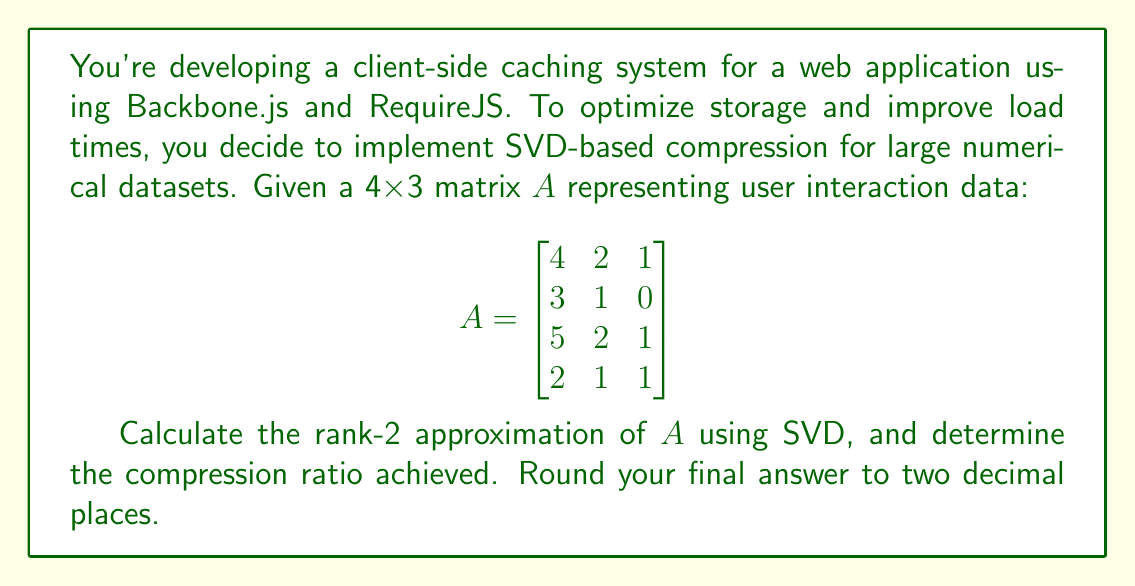Help me with this question. To solve this problem, we'll follow these steps:

1) Compute the SVD of matrix $A$:
   $A = U\Sigma V^T$

2) Truncate the SVD to rank-2:
   $A_2 = U_2\Sigma_2 V_2^T$

3) Calculate the compression ratio

Step 1: Computing the SVD

Using a calculator or computational tool, we get:

$U = \begin{bmatrix}
-0.6412 & -0.0988 & 0.7071 & 0.2887 \\
-0.4263 & -0.2716 & -0.7071 & 0.5000 \\
-0.6284 & 0.0494 & 0 & -0.7761 \\
-0.1311 & 0.9563 & 0 & 0.2613
\end{bmatrix}$

$\Sigma = \begin{bmatrix}
7.3485 & 0 & 0 \\
0 & 0.8564 & 0 \\
0 & 0 & 0.3660 \\
0 & 0 & 0
\end{bmatrix}$

$V^T = \begin{bmatrix}
-0.9098 & -0.4128 & -0.0516 \\
0.3816 & -0.7269 & -0.5735 \\
-0.1613 & 0.5488 & -0.8178
\end{bmatrix}$

Step 2: Truncating to rank-2

For the rank-2 approximation, we keep only the first two columns of $U$, first two rows of $V^T$, and the 2x2 upper-left submatrix of $\Sigma$:

$U_2 = \begin{bmatrix}
-0.6412 & -0.0988 \\
-0.4263 & -0.2716 \\
-0.6284 & 0.0494 \\
-0.1311 & 0.9563
\end{bmatrix}$

$\Sigma_2 = \begin{bmatrix}
7.3485 & 0 \\
0 & 0.8564
\end{bmatrix}$

$V_2^T = \begin{bmatrix}
-0.9098 & -0.4128 & -0.0516 \\
0.3816 & -0.7269 & -0.5735
\end{bmatrix}$

Step 3: Calculating the compression ratio

Original data size: 4 x 3 = 12 elements
Compressed data size: (4 x 2) + (2 x 2) + (2 x 3) = 8 + 4 + 6 = 18 elements

Compression ratio = Original size / Compressed size
                  = 12 / 18 = 0.6667

Note that this compression ratio is greater than 1, indicating that the "compressed" version actually requires more storage than the original. This is because our matrix is small, and the overhead of storing the decomposed matrices outweighs the benefits of truncation. SVD compression becomes more effective for larger matrices.
Answer: The compression ratio is 0.67 (rounded to two decimal places). 